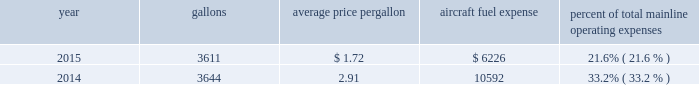Table of contents certain union-represented american mainline employees are covered by agreements that are not currently amendable .
Until those agreements become amendable , negotiations for jcbas will be conducted outside the traditional rla bargaining process described above , and , in the meantime , no self-help will be permissible .
The piedmont mechanics and stock clerks and the psa dispatchers have agreements that are now amendable and are engaged in traditional rla negotiations .
None of the unions representing our employees presently may lawfully engage in concerted refusals to work , such as strikes , slow-downs , sick-outs or other similar activity , against us .
Nonetheless , there is a risk that disgruntled employees , either with or without union involvement , could engage in one or more concerted refusals to work that could individually or collectively harm the operation of our airline and impair our financial performance .
For more discussion , see part i , item 1a .
Risk factors 2013 201cunion disputes , employee strikes and other labor-related disruptions may adversely affect our operations . 201d aircraft fuel our operations and financial results are significantly affected by the availability and price of jet fuel .
Based on our 2016 forecasted mainline and regional fuel consumption , we estimate that , as of december 31 , 2015 , a one cent per gallon increase in aviation fuel price would increase our 2016 annual fuel expense by $ 44 million .
The table shows annual aircraft fuel consumption and costs , including taxes , for our mainline operations for 2015 and 2014 ( gallons and aircraft fuel expense in millions ) .
Year gallons average price per gallon aircraft fuel expense percent of total mainline operating expenses .
Total fuel expenses for our wholly-owned and third-party regional carriers operating under capacity purchase agreements of american were $ 1.2 billion and $ 2.0 billion for the years ended december 31 , 2015 and 2014 , respectively .
As of december 31 , 2015 , we did not have any fuel hedging contracts outstanding to hedge our fuel consumption .
As such , and assuming we do not enter into any future transactions to hedge our fuel consumption , we will continue to be fully exposed to fluctuations in fuel prices .
Our current policy is not to enter into transactions to hedge our fuel consumption , although we review that policy from time to time based on market conditions and other factors .
Fuel prices have fluctuated substantially over the past several years .
We cannot predict the future availability , price volatility or cost of aircraft fuel .
Natural disasters , political disruptions or wars involving oil-producing countries , changes in fuel-related governmental policy , the strength of the u.s .
Dollar against foreign currencies , changes in access to petroleum product pipelines and terminals , speculation in the energy futures markets , changes in aircraft fuel production capacity , environmental concerns and other unpredictable events may result in fuel supply shortages , additional fuel price volatility and cost increases in the future .
See part i , item 1a .
Risk factors 2013 201cour business is dependent on the price and availability of aircraft fuel .
Continued periods of high volatility in fuel costs , increased fuel prices and significant disruptions in the supply of aircraft fuel could have a significant negative impact on our operating results and liquidity . 201d insurance we maintain insurance of the types that we believe are customary in the airline industry , including insurance for public liability , passenger liability , property damage , and all-risk coverage for damage to our aircraft .
Principal coverage includes liability for injury to members of the public , including passengers , damage to .
In 2015 what were the total mainline operating expenses in millions? 
Computations: (6226 / 21.6%)
Answer: 28824.07407. Table of contents certain union-represented american mainline employees are covered by agreements that are not currently amendable .
Until those agreements become amendable , negotiations for jcbas will be conducted outside the traditional rla bargaining process described above , and , in the meantime , no self-help will be permissible .
The piedmont mechanics and stock clerks and the psa dispatchers have agreements that are now amendable and are engaged in traditional rla negotiations .
None of the unions representing our employees presently may lawfully engage in concerted refusals to work , such as strikes , slow-downs , sick-outs or other similar activity , against us .
Nonetheless , there is a risk that disgruntled employees , either with or without union involvement , could engage in one or more concerted refusals to work that could individually or collectively harm the operation of our airline and impair our financial performance .
For more discussion , see part i , item 1a .
Risk factors 2013 201cunion disputes , employee strikes and other labor-related disruptions may adversely affect our operations . 201d aircraft fuel our operations and financial results are significantly affected by the availability and price of jet fuel .
Based on our 2016 forecasted mainline and regional fuel consumption , we estimate that , as of december 31 , 2015 , a one cent per gallon increase in aviation fuel price would increase our 2016 annual fuel expense by $ 44 million .
The table shows annual aircraft fuel consumption and costs , including taxes , for our mainline operations for 2015 and 2014 ( gallons and aircraft fuel expense in millions ) .
Year gallons average price per gallon aircraft fuel expense percent of total mainline operating expenses .
Total fuel expenses for our wholly-owned and third-party regional carriers operating under capacity purchase agreements of american were $ 1.2 billion and $ 2.0 billion for the years ended december 31 , 2015 and 2014 , respectively .
As of december 31 , 2015 , we did not have any fuel hedging contracts outstanding to hedge our fuel consumption .
As such , and assuming we do not enter into any future transactions to hedge our fuel consumption , we will continue to be fully exposed to fluctuations in fuel prices .
Our current policy is not to enter into transactions to hedge our fuel consumption , although we review that policy from time to time based on market conditions and other factors .
Fuel prices have fluctuated substantially over the past several years .
We cannot predict the future availability , price volatility or cost of aircraft fuel .
Natural disasters , political disruptions or wars involving oil-producing countries , changes in fuel-related governmental policy , the strength of the u.s .
Dollar against foreign currencies , changes in access to petroleum product pipelines and terminals , speculation in the energy futures markets , changes in aircraft fuel production capacity , environmental concerns and other unpredictable events may result in fuel supply shortages , additional fuel price volatility and cost increases in the future .
See part i , item 1a .
Risk factors 2013 201cour business is dependent on the price and availability of aircraft fuel .
Continued periods of high volatility in fuel costs , increased fuel prices and significant disruptions in the supply of aircraft fuel could have a significant negative impact on our operating results and liquidity . 201d insurance we maintain insurance of the types that we believe are customary in the airline industry , including insurance for public liability , passenger liability , property damage , and all-risk coverage for damage to our aircraft .
Principal coverage includes liability for injury to members of the public , including passengers , damage to .
What was total mainline operating expenses for 2015? 
Computations: (6226 / 21.6%)
Answer: 28824.07407. 